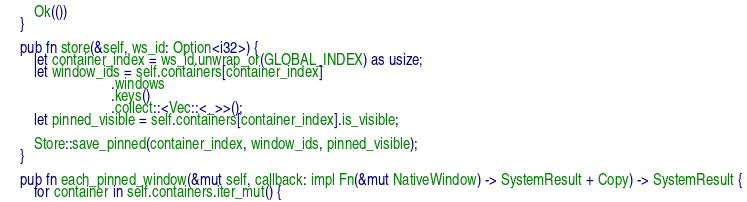Convert code to text. <code><loc_0><loc_0><loc_500><loc_500><_Rust_>        Ok(())
    }

    pub fn store(&self, ws_id: Option<i32>) {
        let container_index = ws_id.unwrap_or(GLOBAL_INDEX) as usize; 
        let window_ids = self.containers[container_index]
                             .windows
                             .keys()
                             .collect::<Vec::<_>>();
        let pinned_visible = self.containers[container_index].is_visible;

        Store::save_pinned(container_index, window_ids, pinned_visible);
    }

    pub fn each_pinned_window(&mut self, callback: impl Fn(&mut NativeWindow) -> SystemResult + Copy) -> SystemResult {
        for container in self.containers.iter_mut() {</code> 